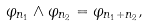Convert formula to latex. <formula><loc_0><loc_0><loc_500><loc_500>\varphi _ { n _ { 1 } } \wedge \varphi _ { n _ { 2 } } = \varphi _ { n _ { 1 } + n _ { 2 } } ,</formula> 